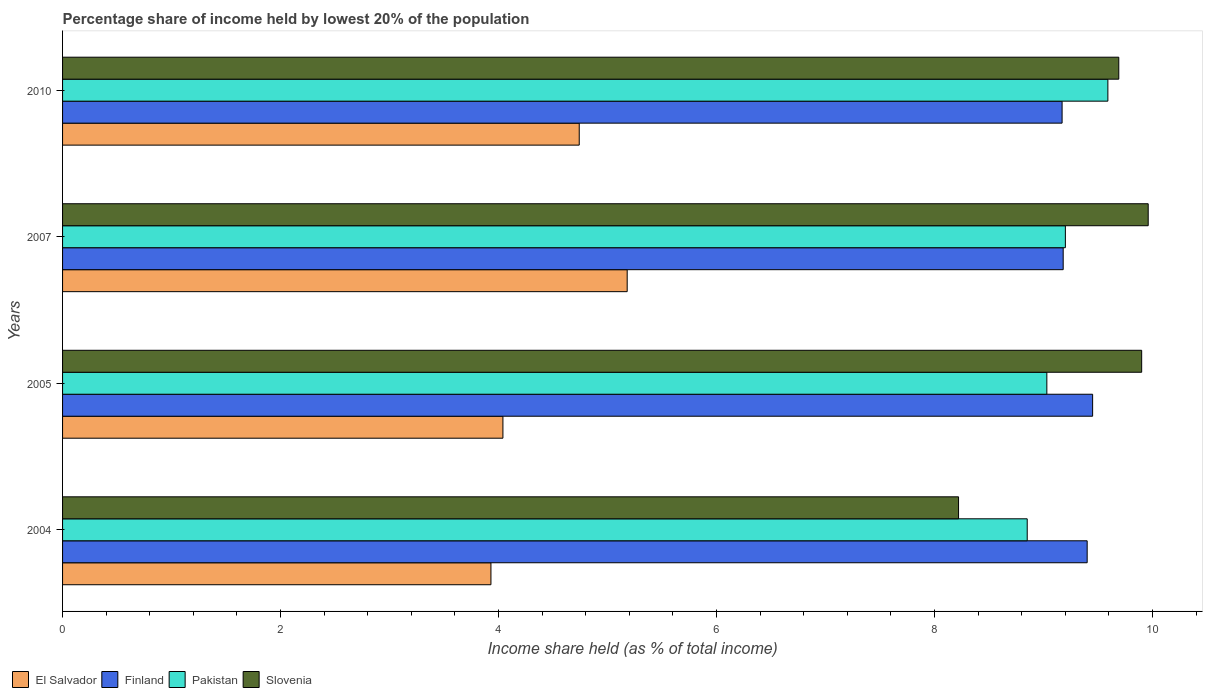Are the number of bars per tick equal to the number of legend labels?
Ensure brevity in your answer.  Yes. What is the label of the 1st group of bars from the top?
Your response must be concise. 2010. In how many cases, is the number of bars for a given year not equal to the number of legend labels?
Keep it short and to the point. 0. Across all years, what is the maximum percentage share of income held by lowest 20% of the population in Slovenia?
Provide a succinct answer. 9.96. Across all years, what is the minimum percentage share of income held by lowest 20% of the population in Slovenia?
Give a very brief answer. 8.22. In which year was the percentage share of income held by lowest 20% of the population in Pakistan minimum?
Provide a short and direct response. 2004. What is the total percentage share of income held by lowest 20% of the population in Slovenia in the graph?
Your answer should be very brief. 37.77. What is the difference between the percentage share of income held by lowest 20% of the population in Pakistan in 2004 and that in 2005?
Offer a terse response. -0.18. What is the difference between the percentage share of income held by lowest 20% of the population in Finland in 2004 and the percentage share of income held by lowest 20% of the population in Slovenia in 2007?
Ensure brevity in your answer.  -0.56. What is the average percentage share of income held by lowest 20% of the population in El Salvador per year?
Keep it short and to the point. 4.47. In the year 2005, what is the difference between the percentage share of income held by lowest 20% of the population in Slovenia and percentage share of income held by lowest 20% of the population in Pakistan?
Provide a short and direct response. 0.87. What is the ratio of the percentage share of income held by lowest 20% of the population in El Salvador in 2004 to that in 2007?
Give a very brief answer. 0.76. Is the percentage share of income held by lowest 20% of the population in Pakistan in 2004 less than that in 2007?
Give a very brief answer. Yes. What is the difference between the highest and the second highest percentage share of income held by lowest 20% of the population in Pakistan?
Your answer should be very brief. 0.39. What is the difference between the highest and the lowest percentage share of income held by lowest 20% of the population in El Salvador?
Give a very brief answer. 1.25. In how many years, is the percentage share of income held by lowest 20% of the population in El Salvador greater than the average percentage share of income held by lowest 20% of the population in El Salvador taken over all years?
Your answer should be very brief. 2. Is it the case that in every year, the sum of the percentage share of income held by lowest 20% of the population in Pakistan and percentage share of income held by lowest 20% of the population in Slovenia is greater than the sum of percentage share of income held by lowest 20% of the population in El Salvador and percentage share of income held by lowest 20% of the population in Finland?
Give a very brief answer. No. What does the 1st bar from the top in 2005 represents?
Offer a terse response. Slovenia. How many years are there in the graph?
Make the answer very short. 4. What is the difference between two consecutive major ticks on the X-axis?
Your response must be concise. 2. Are the values on the major ticks of X-axis written in scientific E-notation?
Provide a short and direct response. No. How many legend labels are there?
Give a very brief answer. 4. What is the title of the graph?
Your answer should be very brief. Percentage share of income held by lowest 20% of the population. What is the label or title of the X-axis?
Keep it short and to the point. Income share held (as % of total income). What is the Income share held (as % of total income) of El Salvador in 2004?
Ensure brevity in your answer.  3.93. What is the Income share held (as % of total income) of Pakistan in 2004?
Make the answer very short. 8.85. What is the Income share held (as % of total income) in Slovenia in 2004?
Keep it short and to the point. 8.22. What is the Income share held (as % of total income) in El Salvador in 2005?
Provide a succinct answer. 4.04. What is the Income share held (as % of total income) of Finland in 2005?
Your response must be concise. 9.45. What is the Income share held (as % of total income) in Pakistan in 2005?
Your response must be concise. 9.03. What is the Income share held (as % of total income) of El Salvador in 2007?
Provide a short and direct response. 5.18. What is the Income share held (as % of total income) in Finland in 2007?
Your response must be concise. 9.18. What is the Income share held (as % of total income) of Slovenia in 2007?
Provide a short and direct response. 9.96. What is the Income share held (as % of total income) of El Salvador in 2010?
Offer a very short reply. 4.74. What is the Income share held (as % of total income) in Finland in 2010?
Keep it short and to the point. 9.17. What is the Income share held (as % of total income) of Pakistan in 2010?
Provide a succinct answer. 9.59. What is the Income share held (as % of total income) of Slovenia in 2010?
Your answer should be compact. 9.69. Across all years, what is the maximum Income share held (as % of total income) in El Salvador?
Provide a succinct answer. 5.18. Across all years, what is the maximum Income share held (as % of total income) in Finland?
Your response must be concise. 9.45. Across all years, what is the maximum Income share held (as % of total income) of Pakistan?
Give a very brief answer. 9.59. Across all years, what is the maximum Income share held (as % of total income) in Slovenia?
Ensure brevity in your answer.  9.96. Across all years, what is the minimum Income share held (as % of total income) of El Salvador?
Provide a succinct answer. 3.93. Across all years, what is the minimum Income share held (as % of total income) in Finland?
Keep it short and to the point. 9.17. Across all years, what is the minimum Income share held (as % of total income) of Pakistan?
Make the answer very short. 8.85. Across all years, what is the minimum Income share held (as % of total income) in Slovenia?
Offer a very short reply. 8.22. What is the total Income share held (as % of total income) of El Salvador in the graph?
Offer a very short reply. 17.89. What is the total Income share held (as % of total income) of Finland in the graph?
Your answer should be compact. 37.2. What is the total Income share held (as % of total income) of Pakistan in the graph?
Give a very brief answer. 36.67. What is the total Income share held (as % of total income) in Slovenia in the graph?
Ensure brevity in your answer.  37.77. What is the difference between the Income share held (as % of total income) in El Salvador in 2004 and that in 2005?
Give a very brief answer. -0.11. What is the difference between the Income share held (as % of total income) of Pakistan in 2004 and that in 2005?
Make the answer very short. -0.18. What is the difference between the Income share held (as % of total income) of Slovenia in 2004 and that in 2005?
Give a very brief answer. -1.68. What is the difference between the Income share held (as % of total income) of El Salvador in 2004 and that in 2007?
Ensure brevity in your answer.  -1.25. What is the difference between the Income share held (as % of total income) of Finland in 2004 and that in 2007?
Offer a very short reply. 0.22. What is the difference between the Income share held (as % of total income) of Pakistan in 2004 and that in 2007?
Provide a short and direct response. -0.35. What is the difference between the Income share held (as % of total income) of Slovenia in 2004 and that in 2007?
Provide a short and direct response. -1.74. What is the difference between the Income share held (as % of total income) of El Salvador in 2004 and that in 2010?
Your answer should be very brief. -0.81. What is the difference between the Income share held (as % of total income) in Finland in 2004 and that in 2010?
Provide a succinct answer. 0.23. What is the difference between the Income share held (as % of total income) in Pakistan in 2004 and that in 2010?
Offer a very short reply. -0.74. What is the difference between the Income share held (as % of total income) in Slovenia in 2004 and that in 2010?
Offer a terse response. -1.47. What is the difference between the Income share held (as % of total income) in El Salvador in 2005 and that in 2007?
Provide a succinct answer. -1.14. What is the difference between the Income share held (as % of total income) of Finland in 2005 and that in 2007?
Offer a very short reply. 0.27. What is the difference between the Income share held (as % of total income) of Pakistan in 2005 and that in 2007?
Give a very brief answer. -0.17. What is the difference between the Income share held (as % of total income) in Slovenia in 2005 and that in 2007?
Make the answer very short. -0.06. What is the difference between the Income share held (as % of total income) of Finland in 2005 and that in 2010?
Offer a terse response. 0.28. What is the difference between the Income share held (as % of total income) in Pakistan in 2005 and that in 2010?
Provide a succinct answer. -0.56. What is the difference between the Income share held (as % of total income) in Slovenia in 2005 and that in 2010?
Your answer should be compact. 0.21. What is the difference between the Income share held (as % of total income) of El Salvador in 2007 and that in 2010?
Your answer should be very brief. 0.44. What is the difference between the Income share held (as % of total income) of Finland in 2007 and that in 2010?
Ensure brevity in your answer.  0.01. What is the difference between the Income share held (as % of total income) of Pakistan in 2007 and that in 2010?
Offer a terse response. -0.39. What is the difference between the Income share held (as % of total income) in Slovenia in 2007 and that in 2010?
Your answer should be compact. 0.27. What is the difference between the Income share held (as % of total income) of El Salvador in 2004 and the Income share held (as % of total income) of Finland in 2005?
Provide a short and direct response. -5.52. What is the difference between the Income share held (as % of total income) in El Salvador in 2004 and the Income share held (as % of total income) in Pakistan in 2005?
Make the answer very short. -5.1. What is the difference between the Income share held (as % of total income) in El Salvador in 2004 and the Income share held (as % of total income) in Slovenia in 2005?
Ensure brevity in your answer.  -5.97. What is the difference between the Income share held (as % of total income) in Finland in 2004 and the Income share held (as % of total income) in Pakistan in 2005?
Your answer should be compact. 0.37. What is the difference between the Income share held (as % of total income) in Finland in 2004 and the Income share held (as % of total income) in Slovenia in 2005?
Your answer should be very brief. -0.5. What is the difference between the Income share held (as % of total income) of Pakistan in 2004 and the Income share held (as % of total income) of Slovenia in 2005?
Your response must be concise. -1.05. What is the difference between the Income share held (as % of total income) of El Salvador in 2004 and the Income share held (as % of total income) of Finland in 2007?
Ensure brevity in your answer.  -5.25. What is the difference between the Income share held (as % of total income) in El Salvador in 2004 and the Income share held (as % of total income) in Pakistan in 2007?
Offer a very short reply. -5.27. What is the difference between the Income share held (as % of total income) of El Salvador in 2004 and the Income share held (as % of total income) of Slovenia in 2007?
Your answer should be compact. -6.03. What is the difference between the Income share held (as % of total income) of Finland in 2004 and the Income share held (as % of total income) of Pakistan in 2007?
Provide a succinct answer. 0.2. What is the difference between the Income share held (as % of total income) in Finland in 2004 and the Income share held (as % of total income) in Slovenia in 2007?
Offer a very short reply. -0.56. What is the difference between the Income share held (as % of total income) in Pakistan in 2004 and the Income share held (as % of total income) in Slovenia in 2007?
Ensure brevity in your answer.  -1.11. What is the difference between the Income share held (as % of total income) in El Salvador in 2004 and the Income share held (as % of total income) in Finland in 2010?
Make the answer very short. -5.24. What is the difference between the Income share held (as % of total income) of El Salvador in 2004 and the Income share held (as % of total income) of Pakistan in 2010?
Offer a terse response. -5.66. What is the difference between the Income share held (as % of total income) in El Salvador in 2004 and the Income share held (as % of total income) in Slovenia in 2010?
Your answer should be very brief. -5.76. What is the difference between the Income share held (as % of total income) of Finland in 2004 and the Income share held (as % of total income) of Pakistan in 2010?
Make the answer very short. -0.19. What is the difference between the Income share held (as % of total income) of Finland in 2004 and the Income share held (as % of total income) of Slovenia in 2010?
Your answer should be compact. -0.29. What is the difference between the Income share held (as % of total income) of Pakistan in 2004 and the Income share held (as % of total income) of Slovenia in 2010?
Give a very brief answer. -0.84. What is the difference between the Income share held (as % of total income) in El Salvador in 2005 and the Income share held (as % of total income) in Finland in 2007?
Make the answer very short. -5.14. What is the difference between the Income share held (as % of total income) in El Salvador in 2005 and the Income share held (as % of total income) in Pakistan in 2007?
Your answer should be very brief. -5.16. What is the difference between the Income share held (as % of total income) in El Salvador in 2005 and the Income share held (as % of total income) in Slovenia in 2007?
Offer a very short reply. -5.92. What is the difference between the Income share held (as % of total income) of Finland in 2005 and the Income share held (as % of total income) of Slovenia in 2007?
Ensure brevity in your answer.  -0.51. What is the difference between the Income share held (as % of total income) of Pakistan in 2005 and the Income share held (as % of total income) of Slovenia in 2007?
Provide a succinct answer. -0.93. What is the difference between the Income share held (as % of total income) in El Salvador in 2005 and the Income share held (as % of total income) in Finland in 2010?
Your answer should be compact. -5.13. What is the difference between the Income share held (as % of total income) in El Salvador in 2005 and the Income share held (as % of total income) in Pakistan in 2010?
Offer a terse response. -5.55. What is the difference between the Income share held (as % of total income) in El Salvador in 2005 and the Income share held (as % of total income) in Slovenia in 2010?
Provide a succinct answer. -5.65. What is the difference between the Income share held (as % of total income) of Finland in 2005 and the Income share held (as % of total income) of Pakistan in 2010?
Offer a terse response. -0.14. What is the difference between the Income share held (as % of total income) of Finland in 2005 and the Income share held (as % of total income) of Slovenia in 2010?
Offer a terse response. -0.24. What is the difference between the Income share held (as % of total income) in Pakistan in 2005 and the Income share held (as % of total income) in Slovenia in 2010?
Your answer should be compact. -0.66. What is the difference between the Income share held (as % of total income) in El Salvador in 2007 and the Income share held (as % of total income) in Finland in 2010?
Make the answer very short. -3.99. What is the difference between the Income share held (as % of total income) of El Salvador in 2007 and the Income share held (as % of total income) of Pakistan in 2010?
Provide a short and direct response. -4.41. What is the difference between the Income share held (as % of total income) in El Salvador in 2007 and the Income share held (as % of total income) in Slovenia in 2010?
Offer a terse response. -4.51. What is the difference between the Income share held (as % of total income) in Finland in 2007 and the Income share held (as % of total income) in Pakistan in 2010?
Ensure brevity in your answer.  -0.41. What is the difference between the Income share held (as % of total income) in Finland in 2007 and the Income share held (as % of total income) in Slovenia in 2010?
Offer a very short reply. -0.51. What is the difference between the Income share held (as % of total income) in Pakistan in 2007 and the Income share held (as % of total income) in Slovenia in 2010?
Give a very brief answer. -0.49. What is the average Income share held (as % of total income) in El Salvador per year?
Keep it short and to the point. 4.47. What is the average Income share held (as % of total income) in Finland per year?
Your answer should be very brief. 9.3. What is the average Income share held (as % of total income) in Pakistan per year?
Offer a very short reply. 9.17. What is the average Income share held (as % of total income) of Slovenia per year?
Give a very brief answer. 9.44. In the year 2004, what is the difference between the Income share held (as % of total income) in El Salvador and Income share held (as % of total income) in Finland?
Make the answer very short. -5.47. In the year 2004, what is the difference between the Income share held (as % of total income) in El Salvador and Income share held (as % of total income) in Pakistan?
Ensure brevity in your answer.  -4.92. In the year 2004, what is the difference between the Income share held (as % of total income) in El Salvador and Income share held (as % of total income) in Slovenia?
Your answer should be very brief. -4.29. In the year 2004, what is the difference between the Income share held (as % of total income) in Finland and Income share held (as % of total income) in Pakistan?
Your answer should be very brief. 0.55. In the year 2004, what is the difference between the Income share held (as % of total income) of Finland and Income share held (as % of total income) of Slovenia?
Give a very brief answer. 1.18. In the year 2004, what is the difference between the Income share held (as % of total income) in Pakistan and Income share held (as % of total income) in Slovenia?
Give a very brief answer. 0.63. In the year 2005, what is the difference between the Income share held (as % of total income) in El Salvador and Income share held (as % of total income) in Finland?
Make the answer very short. -5.41. In the year 2005, what is the difference between the Income share held (as % of total income) of El Salvador and Income share held (as % of total income) of Pakistan?
Ensure brevity in your answer.  -4.99. In the year 2005, what is the difference between the Income share held (as % of total income) of El Salvador and Income share held (as % of total income) of Slovenia?
Keep it short and to the point. -5.86. In the year 2005, what is the difference between the Income share held (as % of total income) of Finland and Income share held (as % of total income) of Pakistan?
Provide a short and direct response. 0.42. In the year 2005, what is the difference between the Income share held (as % of total income) in Finland and Income share held (as % of total income) in Slovenia?
Offer a very short reply. -0.45. In the year 2005, what is the difference between the Income share held (as % of total income) in Pakistan and Income share held (as % of total income) in Slovenia?
Make the answer very short. -0.87. In the year 2007, what is the difference between the Income share held (as % of total income) in El Salvador and Income share held (as % of total income) in Finland?
Your answer should be very brief. -4. In the year 2007, what is the difference between the Income share held (as % of total income) of El Salvador and Income share held (as % of total income) of Pakistan?
Your response must be concise. -4.02. In the year 2007, what is the difference between the Income share held (as % of total income) in El Salvador and Income share held (as % of total income) in Slovenia?
Ensure brevity in your answer.  -4.78. In the year 2007, what is the difference between the Income share held (as % of total income) in Finland and Income share held (as % of total income) in Pakistan?
Your answer should be compact. -0.02. In the year 2007, what is the difference between the Income share held (as % of total income) of Finland and Income share held (as % of total income) of Slovenia?
Provide a short and direct response. -0.78. In the year 2007, what is the difference between the Income share held (as % of total income) of Pakistan and Income share held (as % of total income) of Slovenia?
Give a very brief answer. -0.76. In the year 2010, what is the difference between the Income share held (as % of total income) in El Salvador and Income share held (as % of total income) in Finland?
Your response must be concise. -4.43. In the year 2010, what is the difference between the Income share held (as % of total income) in El Salvador and Income share held (as % of total income) in Pakistan?
Your answer should be compact. -4.85. In the year 2010, what is the difference between the Income share held (as % of total income) in El Salvador and Income share held (as % of total income) in Slovenia?
Your response must be concise. -4.95. In the year 2010, what is the difference between the Income share held (as % of total income) of Finland and Income share held (as % of total income) of Pakistan?
Offer a terse response. -0.42. In the year 2010, what is the difference between the Income share held (as % of total income) in Finland and Income share held (as % of total income) in Slovenia?
Ensure brevity in your answer.  -0.52. What is the ratio of the Income share held (as % of total income) of El Salvador in 2004 to that in 2005?
Make the answer very short. 0.97. What is the ratio of the Income share held (as % of total income) in Pakistan in 2004 to that in 2005?
Your answer should be compact. 0.98. What is the ratio of the Income share held (as % of total income) in Slovenia in 2004 to that in 2005?
Ensure brevity in your answer.  0.83. What is the ratio of the Income share held (as % of total income) of El Salvador in 2004 to that in 2007?
Make the answer very short. 0.76. What is the ratio of the Income share held (as % of total income) in Pakistan in 2004 to that in 2007?
Offer a terse response. 0.96. What is the ratio of the Income share held (as % of total income) of Slovenia in 2004 to that in 2007?
Provide a succinct answer. 0.83. What is the ratio of the Income share held (as % of total income) of El Salvador in 2004 to that in 2010?
Ensure brevity in your answer.  0.83. What is the ratio of the Income share held (as % of total income) of Finland in 2004 to that in 2010?
Your answer should be compact. 1.03. What is the ratio of the Income share held (as % of total income) in Pakistan in 2004 to that in 2010?
Offer a terse response. 0.92. What is the ratio of the Income share held (as % of total income) of Slovenia in 2004 to that in 2010?
Provide a succinct answer. 0.85. What is the ratio of the Income share held (as % of total income) of El Salvador in 2005 to that in 2007?
Your response must be concise. 0.78. What is the ratio of the Income share held (as % of total income) of Finland in 2005 to that in 2007?
Your answer should be very brief. 1.03. What is the ratio of the Income share held (as % of total income) in Pakistan in 2005 to that in 2007?
Provide a short and direct response. 0.98. What is the ratio of the Income share held (as % of total income) of El Salvador in 2005 to that in 2010?
Your response must be concise. 0.85. What is the ratio of the Income share held (as % of total income) in Finland in 2005 to that in 2010?
Your response must be concise. 1.03. What is the ratio of the Income share held (as % of total income) of Pakistan in 2005 to that in 2010?
Give a very brief answer. 0.94. What is the ratio of the Income share held (as % of total income) in Slovenia in 2005 to that in 2010?
Offer a very short reply. 1.02. What is the ratio of the Income share held (as % of total income) of El Salvador in 2007 to that in 2010?
Provide a succinct answer. 1.09. What is the ratio of the Income share held (as % of total income) of Pakistan in 2007 to that in 2010?
Your response must be concise. 0.96. What is the ratio of the Income share held (as % of total income) of Slovenia in 2007 to that in 2010?
Offer a terse response. 1.03. What is the difference between the highest and the second highest Income share held (as % of total income) in El Salvador?
Offer a terse response. 0.44. What is the difference between the highest and the second highest Income share held (as % of total income) of Pakistan?
Make the answer very short. 0.39. What is the difference between the highest and the second highest Income share held (as % of total income) in Slovenia?
Your answer should be compact. 0.06. What is the difference between the highest and the lowest Income share held (as % of total income) in El Salvador?
Ensure brevity in your answer.  1.25. What is the difference between the highest and the lowest Income share held (as % of total income) in Finland?
Your response must be concise. 0.28. What is the difference between the highest and the lowest Income share held (as % of total income) in Pakistan?
Give a very brief answer. 0.74. What is the difference between the highest and the lowest Income share held (as % of total income) of Slovenia?
Offer a very short reply. 1.74. 